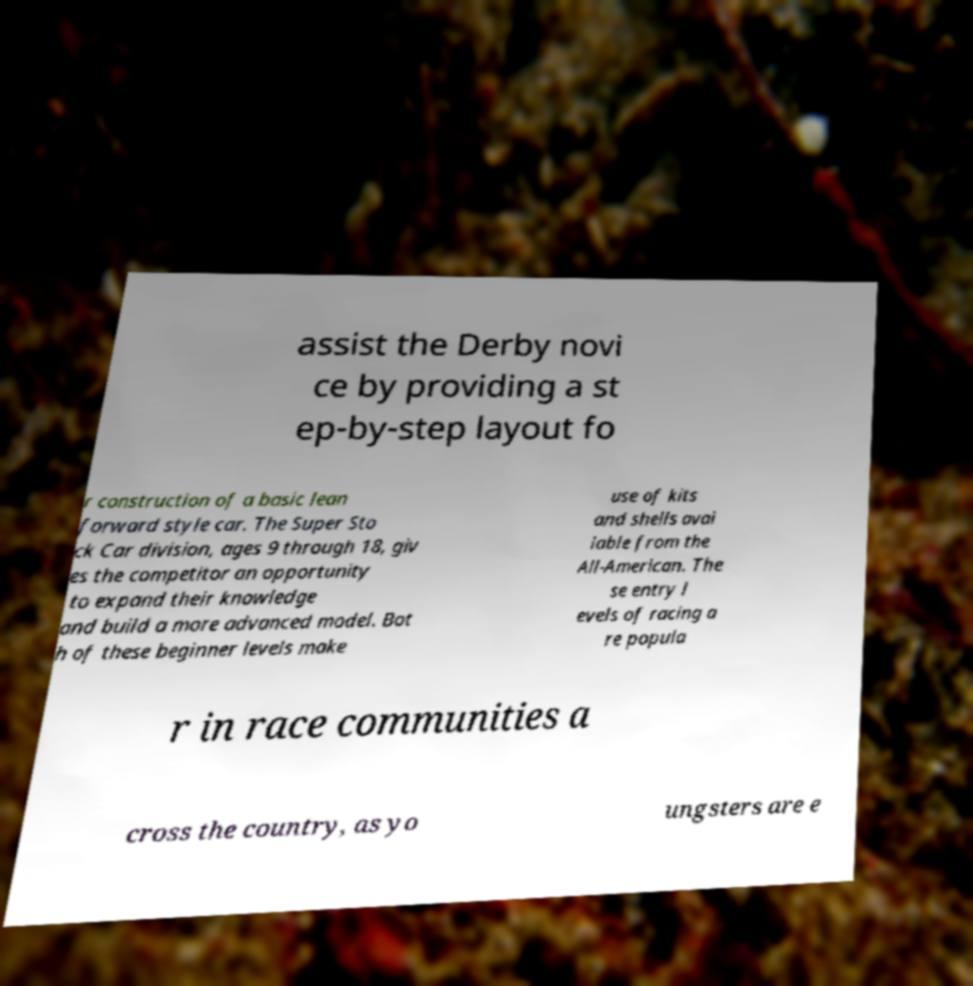Could you assist in decoding the text presented in this image and type it out clearly? assist the Derby novi ce by providing a st ep-by-step layout fo r construction of a basic lean forward style car. The Super Sto ck Car division, ages 9 through 18, giv es the competitor an opportunity to expand their knowledge and build a more advanced model. Bot h of these beginner levels make use of kits and shells avai lable from the All-American. The se entry l evels of racing a re popula r in race communities a cross the country, as yo ungsters are e 